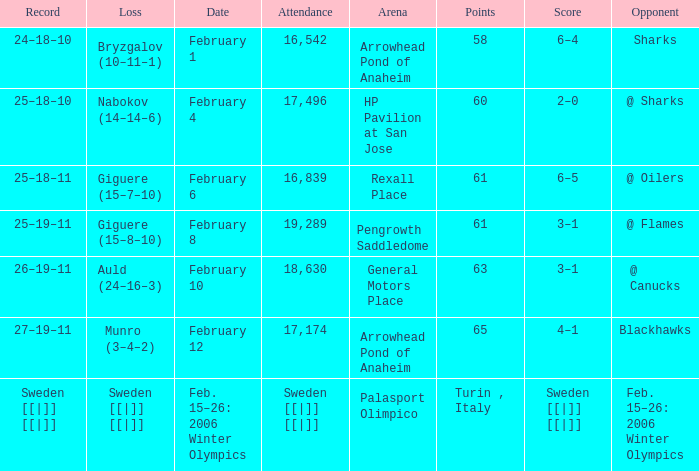What is the record at Palasport Olimpico? Sweden [[|]] [[|]]. 